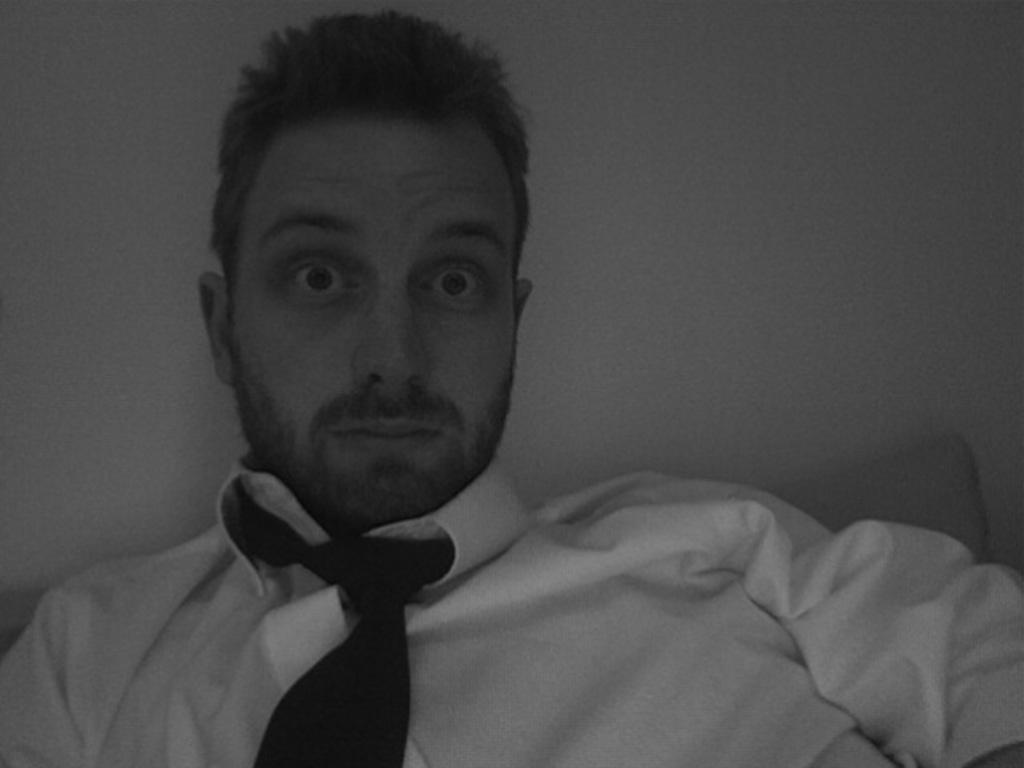What is the main subject of the image? There is a person in the image. What is the person wearing on their upper body? The person is wearing a white shirt and a tie. What can be observed about the person's hair? The person has black hair. What is the color of the background in the image? The background of the image is white. What is the price of the stew being served in the image? There is no stew present in the image, so it is not possible to determine its price. 